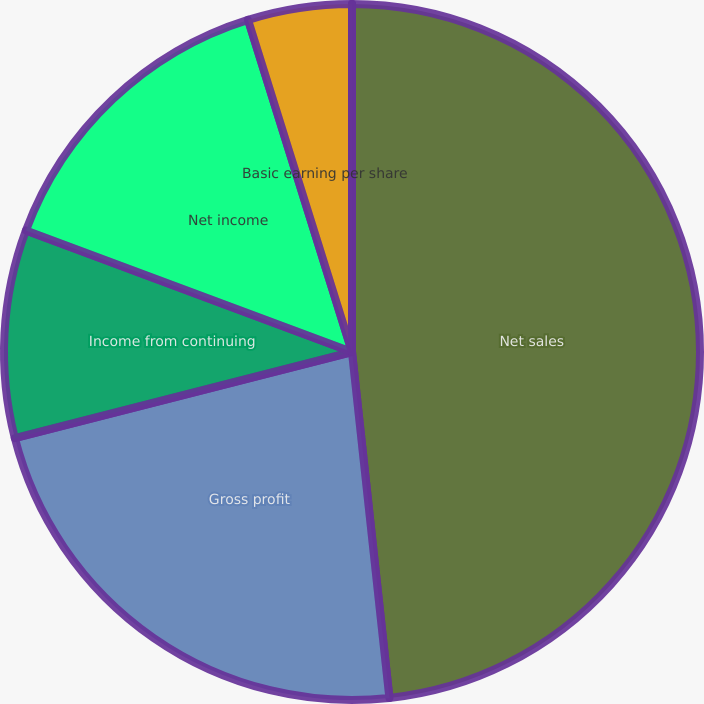Convert chart. <chart><loc_0><loc_0><loc_500><loc_500><pie_chart><fcel>Net sales<fcel>Gross profit<fcel>Income from continuing<fcel>Net income<fcel>Basic earning per share<fcel>Diluted earnings per share<nl><fcel>48.29%<fcel>22.74%<fcel>9.66%<fcel>14.49%<fcel>4.83%<fcel>0.0%<nl></chart> 